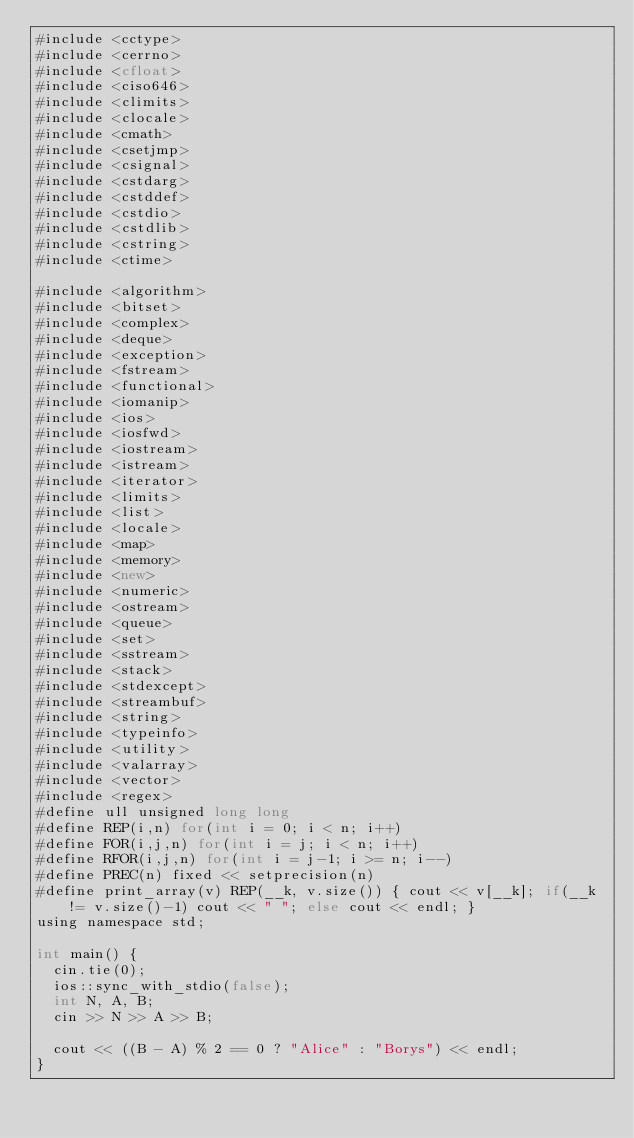Convert code to text. <code><loc_0><loc_0><loc_500><loc_500><_D_>#include <cctype>
#include <cerrno>
#include <cfloat>
#include <ciso646>
#include <climits>
#include <clocale>
#include <cmath>
#include <csetjmp>
#include <csignal>
#include <cstdarg>
#include <cstddef>
#include <cstdio>
#include <cstdlib>
#include <cstring>
#include <ctime>

#include <algorithm>
#include <bitset>
#include <complex>
#include <deque>
#include <exception>
#include <fstream>
#include <functional>
#include <iomanip>
#include <ios>
#include <iosfwd>
#include <iostream>
#include <istream>
#include <iterator>
#include <limits>
#include <list>
#include <locale>
#include <map>
#include <memory>
#include <new>
#include <numeric>
#include <ostream>
#include <queue>
#include <set>
#include <sstream>
#include <stack>
#include <stdexcept>
#include <streambuf>
#include <string>
#include <typeinfo>
#include <utility>
#include <valarray>
#include <vector>
#include <regex>
#define ull unsigned long long
#define REP(i,n) for(int i = 0; i < n; i++)
#define FOR(i,j,n) for(int i = j; i < n; i++)
#define RFOR(i,j,n) for(int i = j-1; i >= n; i--)
#define PREC(n) fixed << setprecision(n)
#define print_array(v) REP(__k, v.size()) { cout << v[__k]; if(__k != v.size()-1) cout << " "; else cout << endl; }
using namespace std;

int main() {
	cin.tie(0);
	ios::sync_with_stdio(false);
	int N, A, B;
	cin >> N >> A >> B;

	cout << ((B - A) % 2 == 0 ? "Alice" : "Borys") << endl;
}</code> 